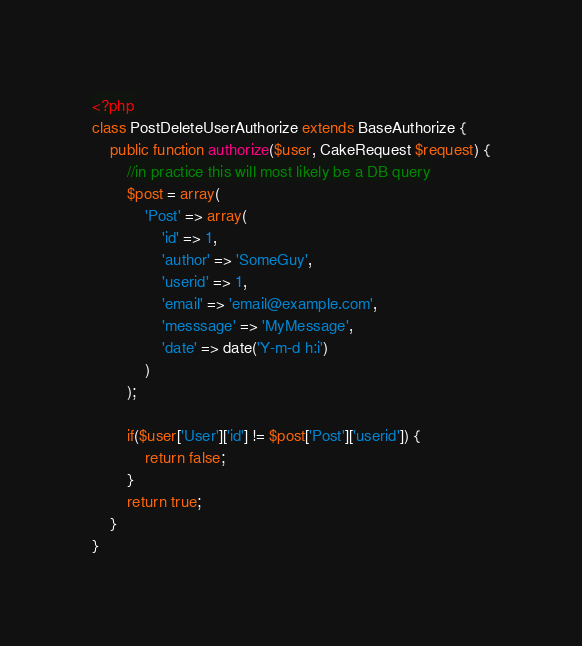Convert code to text. <code><loc_0><loc_0><loc_500><loc_500><_PHP_><?php
class PostDeleteUserAuthorize extends BaseAuthorize {
    public function authorize($user, CakeRequest $request) {
        //in practice this will most likely be a DB query
        $post = array(
            'Post' => array(
                'id' => 1,
                'author' => 'SomeGuy',
                'userid' => 1,
                'email' => 'email@example.com',
                'messsage' => 'MyMessage',
                'date' => date('Y-m-d h:i')
            )
        );
        
        if($user['User']['id'] != $post['Post']['userid']) {
            return false;
        }
        return true;
    }
}</code> 